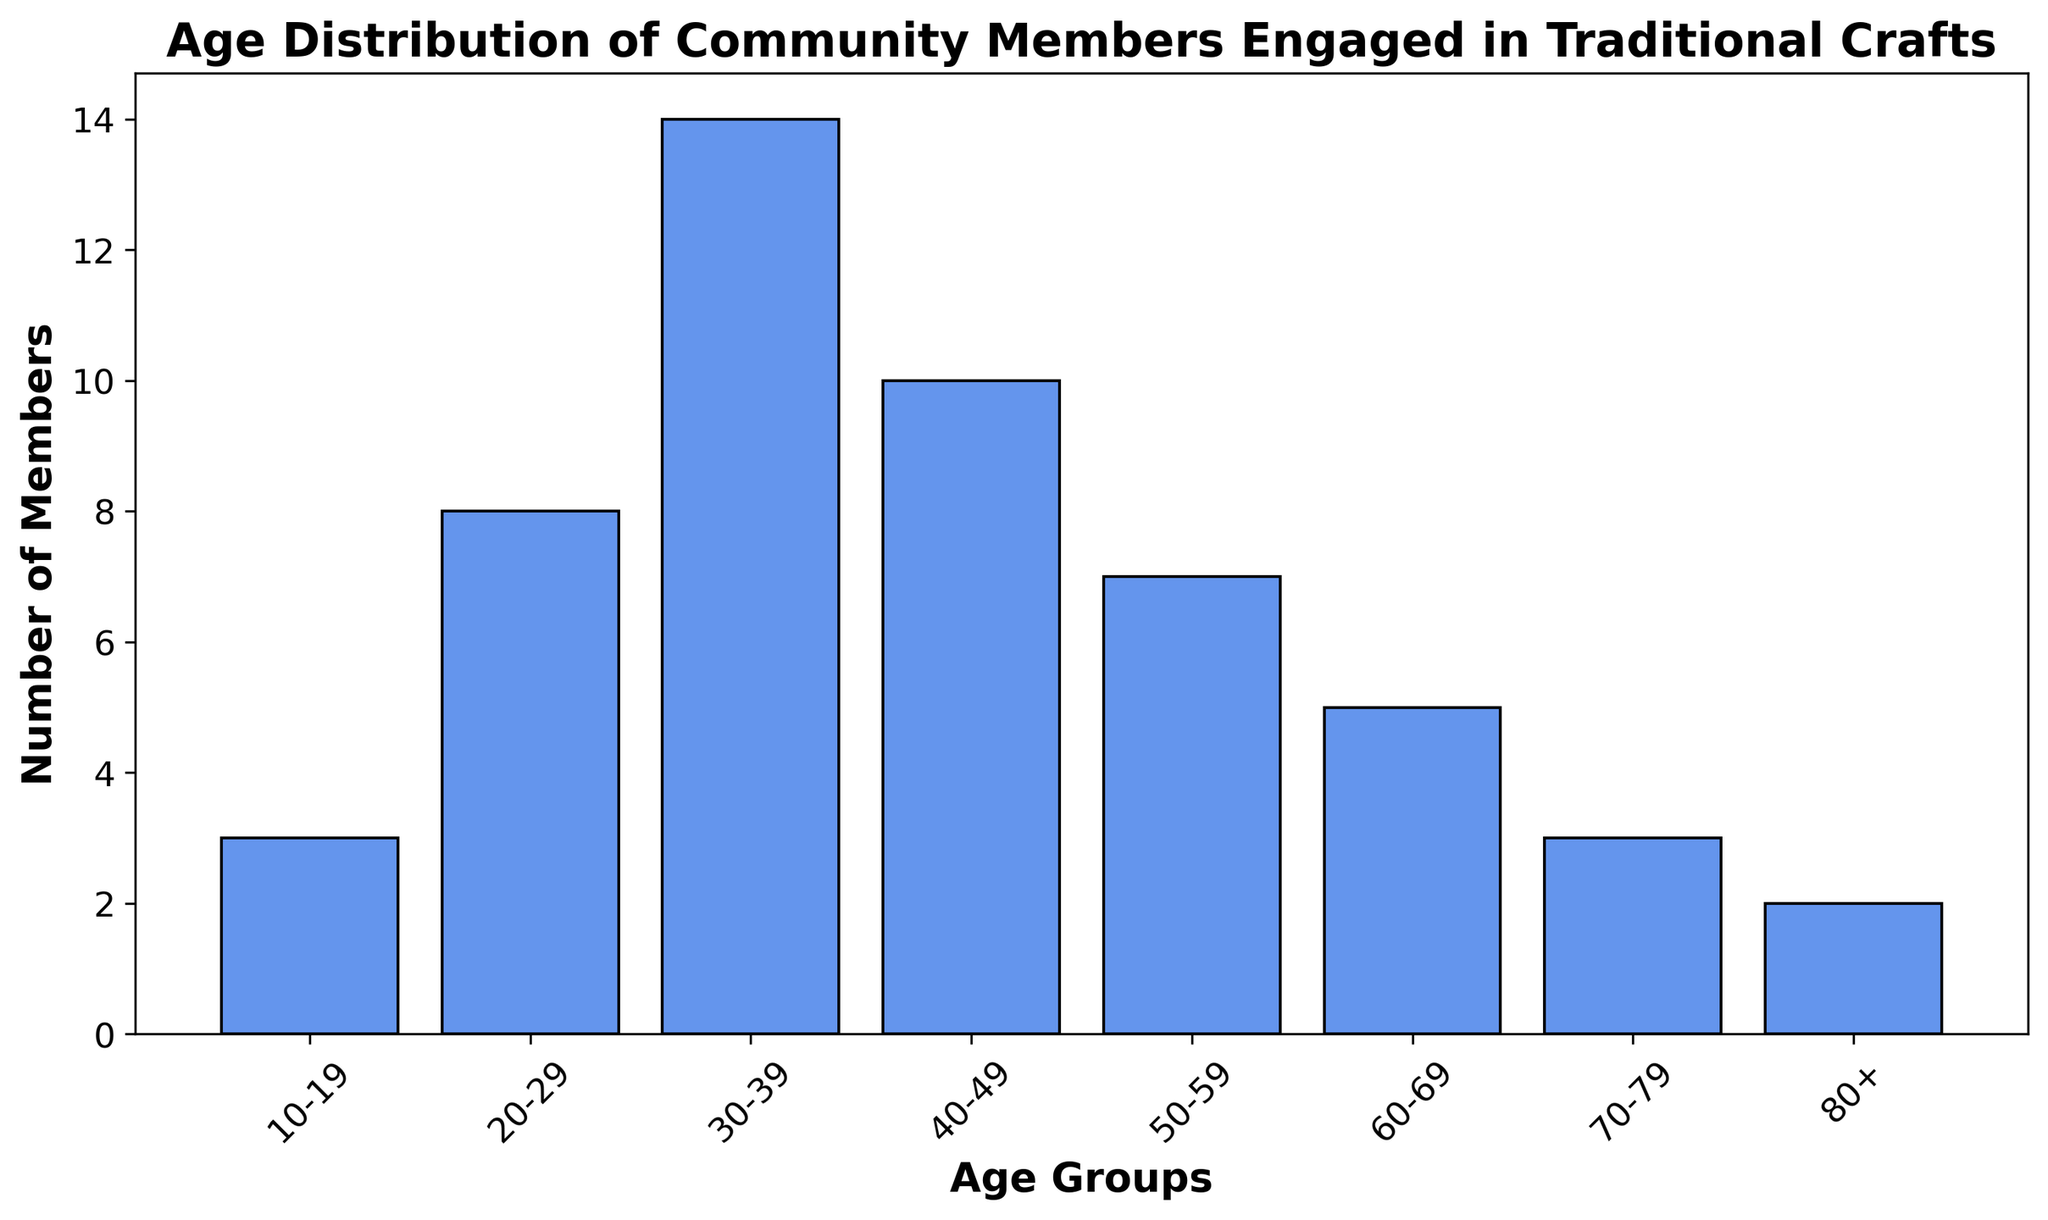Which age group has the highest number of members engaged in traditional crafts? By visually inspecting the heights of the bars, the age group 30-39 has the tallest bar, indicating the highest count of members.
Answer: 30-39 How many age groups have fewer than 5 members engaged in traditional crafts? By looking at the heights of the bars and their corresponding labels, the age groups 10-19, 70-79, and 80+ each have fewer than 5 members.
Answer: 3 What is the total number of members aged 40 and above engaged in traditional crafts? Adding the counts for age groups 40-49 (10), 50-59 (7), 60-69 (5), 70-79 (3), and 80+ (2): 10 + 7 + 5 + 3 + 2 = 27.
Answer: 27 Compare the number of members in the 20-29 age group with the 50-59 age group. Which group has more members? The bar for the 20-29 age group is taller compared to the one for the 50-59 group. Specifically, 20-29 has 8 members while 50-59 has 7 members.
Answer: 20-29 Which color is used for the bars representing the age groups? By visually inspecting the bars, all bars are colored in a shade of blue known as cornflower blue.
Answer: blue What is the difference in the number of members between the age groups 40-49 and 30-39? Subtract the count of members in the 40-49 group (10) from the 30-39 group (14): 14 - 10 = 4.
Answer: 4 Which three age groups have the fewest members engaged in traditional crafts? By visually comparing the bar heights, the age groups 10-19, 70-79, and 80+ have the fewest members with counts of 3, 3, and 2 respectively.
Answer: 10-19, 70-79, 80+ How many more members are there in the age group 30-39 compared to the age group 20-29? Subtract the count for the 20-29 group (8) from the 30-39 group (14): 14 - 8 = 6.
Answer: 6 